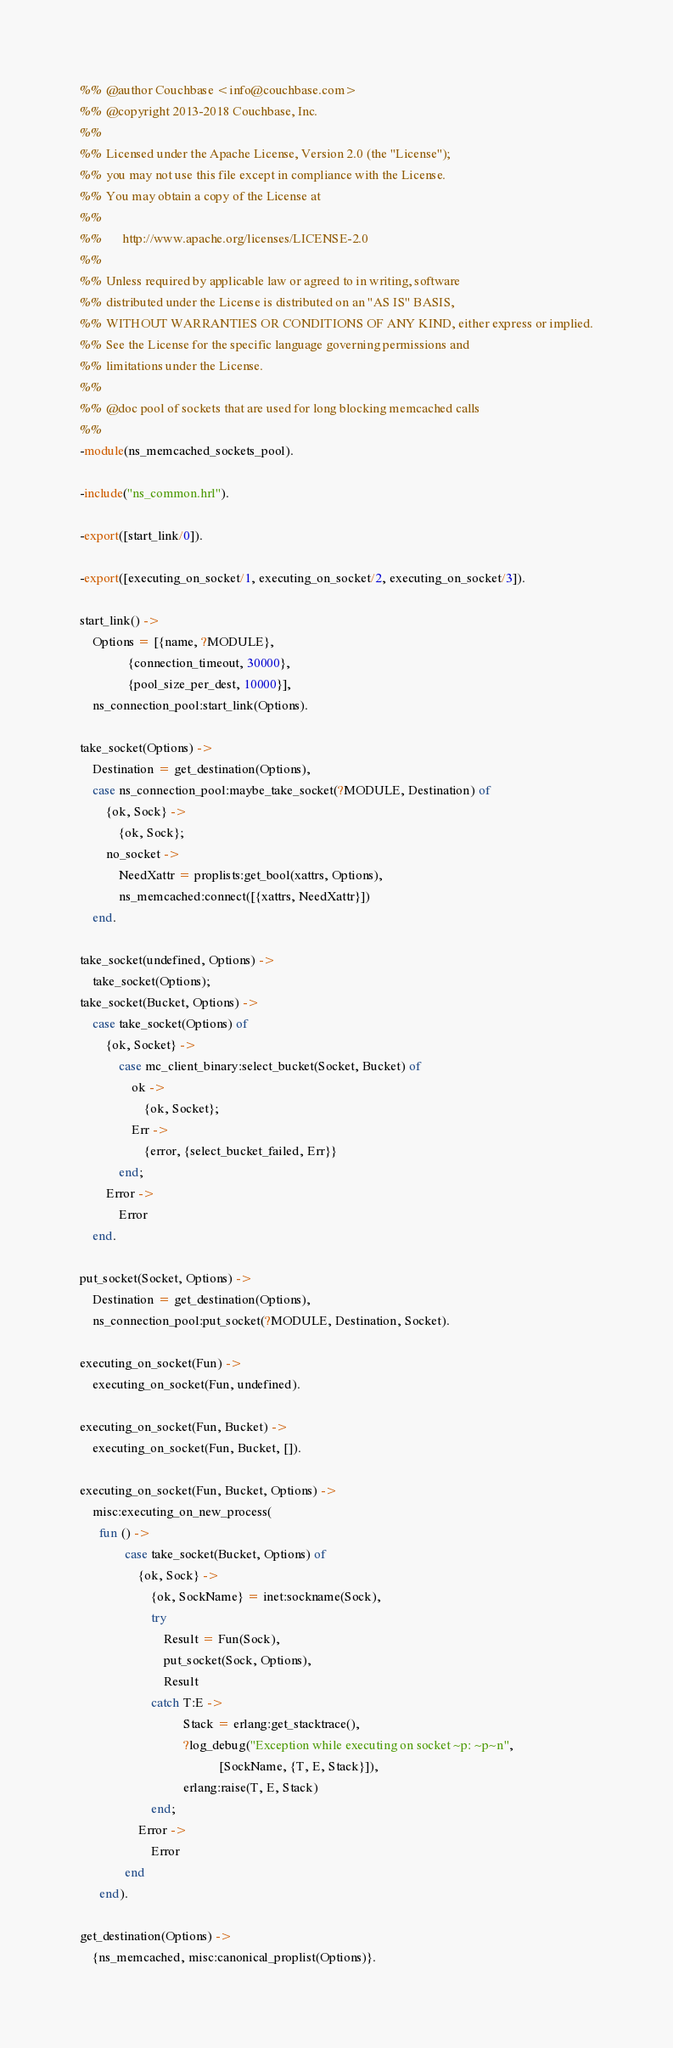<code> <loc_0><loc_0><loc_500><loc_500><_Erlang_>%% @author Couchbase <info@couchbase.com>
%% @copyright 2013-2018 Couchbase, Inc.
%%
%% Licensed under the Apache License, Version 2.0 (the "License");
%% you may not use this file except in compliance with the License.
%% You may obtain a copy of the License at
%%
%%      http://www.apache.org/licenses/LICENSE-2.0
%%
%% Unless required by applicable law or agreed to in writing, software
%% distributed under the License is distributed on an "AS IS" BASIS,
%% WITHOUT WARRANTIES OR CONDITIONS OF ANY KIND, either express or implied.
%% See the License for the specific language governing permissions and
%% limitations under the License.
%%
%% @doc pool of sockets that are used for long blocking memcached calls
%%
-module(ns_memcached_sockets_pool).

-include("ns_common.hrl").

-export([start_link/0]).

-export([executing_on_socket/1, executing_on_socket/2, executing_on_socket/3]).

start_link() ->
    Options = [{name, ?MODULE},
               {connection_timeout, 30000},
               {pool_size_per_dest, 10000}],
    ns_connection_pool:start_link(Options).

take_socket(Options) ->
    Destination = get_destination(Options),
    case ns_connection_pool:maybe_take_socket(?MODULE, Destination) of
        {ok, Sock} ->
            {ok, Sock};
        no_socket ->
            NeedXattr = proplists:get_bool(xattrs, Options),
            ns_memcached:connect([{xattrs, NeedXattr}])
    end.

take_socket(undefined, Options) ->
    take_socket(Options);
take_socket(Bucket, Options) ->
    case take_socket(Options) of
        {ok, Socket} ->
            case mc_client_binary:select_bucket(Socket, Bucket) of
                ok ->
                    {ok, Socket};
                Err ->
                    {error, {select_bucket_failed, Err}}
            end;
        Error ->
            Error
    end.

put_socket(Socket, Options) ->
    Destination = get_destination(Options),
    ns_connection_pool:put_socket(?MODULE, Destination, Socket).

executing_on_socket(Fun) ->
    executing_on_socket(Fun, undefined).

executing_on_socket(Fun, Bucket) ->
    executing_on_socket(Fun, Bucket, []).

executing_on_socket(Fun, Bucket, Options) ->
    misc:executing_on_new_process(
      fun () ->
              case take_socket(Bucket, Options) of
                  {ok, Sock} ->
                      {ok, SockName} = inet:sockname(Sock),
                      try
                          Result = Fun(Sock),
                          put_socket(Sock, Options),
                          Result
                      catch T:E ->
                                Stack = erlang:get_stacktrace(),
                                ?log_debug("Exception while executing on socket ~p: ~p~n",
                                           [SockName, {T, E, Stack}]),
                                erlang:raise(T, E, Stack)
                      end;
                  Error ->
                      Error
              end
      end).

get_destination(Options) ->
    {ns_memcached, misc:canonical_proplist(Options)}.
</code> 